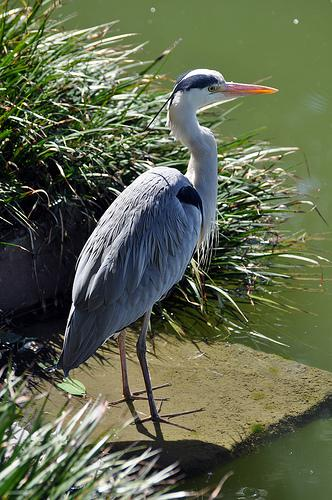Question: when was this picture taken?
Choices:
A. One second ago.
B. 100 years ago.
C. Yesterday.
D. St. Patrick's Day.
Answer with the letter. Answer: C Question: what is the bird doing?
Choices:
A. Flying.
B. Resting.
C. Eating.
D. Posing.
Answer with the letter. Answer: B 